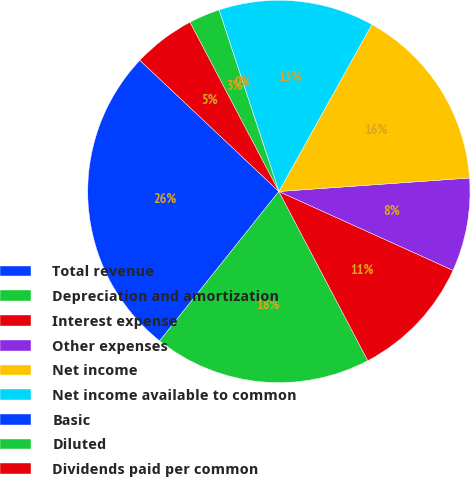Convert chart. <chart><loc_0><loc_0><loc_500><loc_500><pie_chart><fcel>Total revenue<fcel>Depreciation and amortization<fcel>Interest expense<fcel>Other expenses<fcel>Net income<fcel>Net income available to common<fcel>Basic<fcel>Diluted<fcel>Dividends paid per common<nl><fcel>26.32%<fcel>18.42%<fcel>10.53%<fcel>7.89%<fcel>15.79%<fcel>13.16%<fcel>0.0%<fcel>2.63%<fcel>5.26%<nl></chart> 